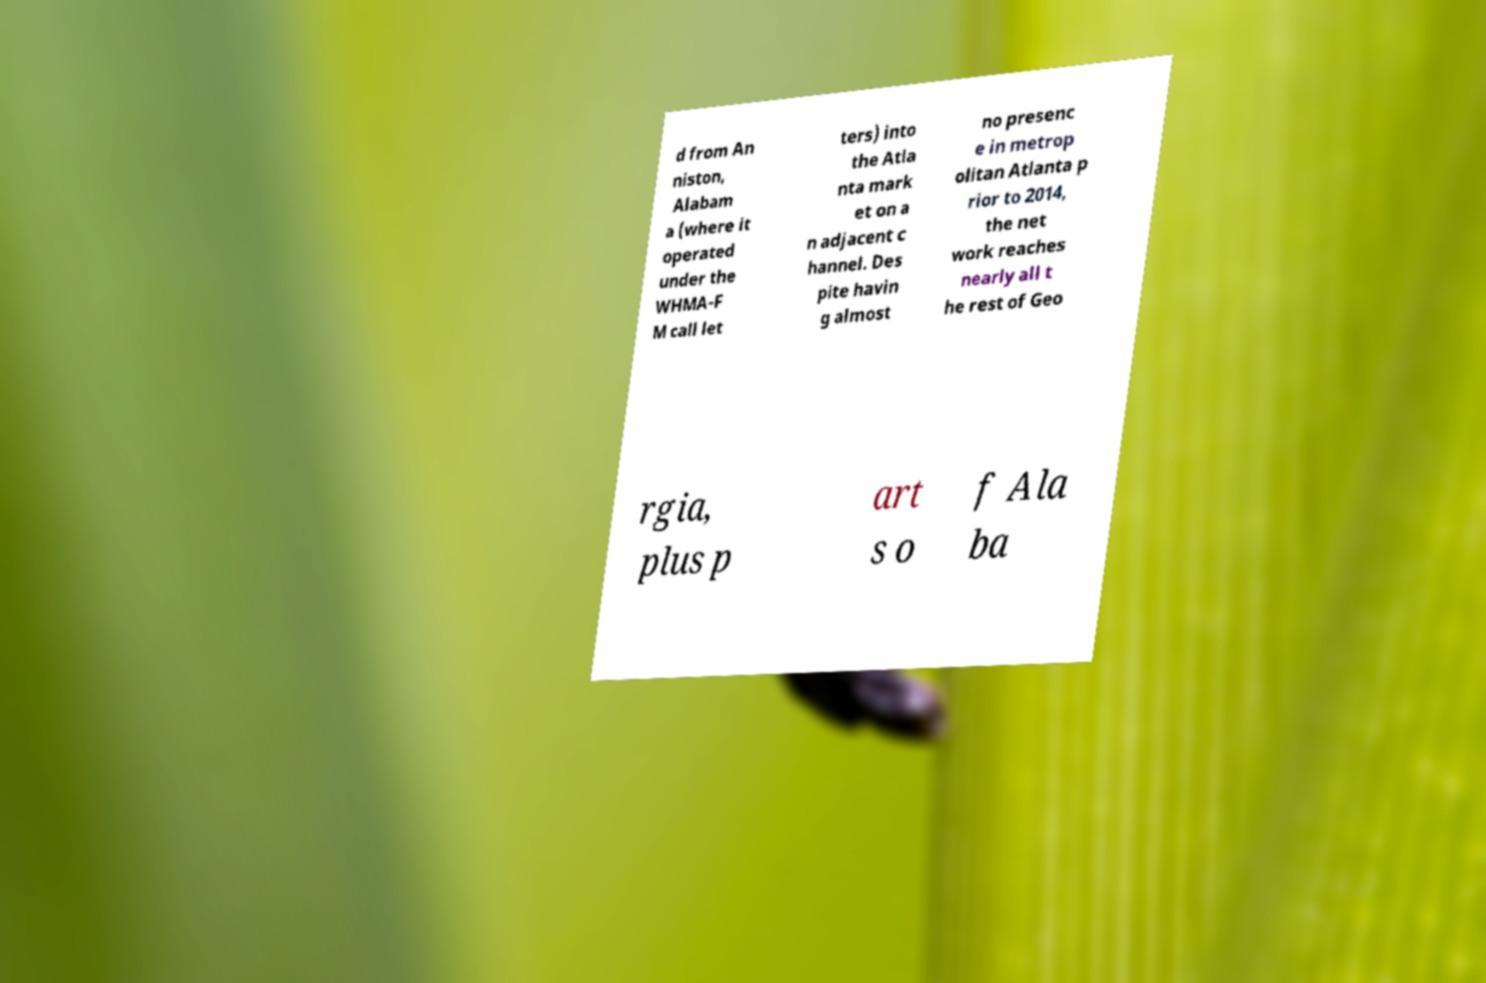Could you extract and type out the text from this image? d from An niston, Alabam a (where it operated under the WHMA-F M call let ters) into the Atla nta mark et on a n adjacent c hannel. Des pite havin g almost no presenc e in metrop olitan Atlanta p rior to 2014, the net work reaches nearly all t he rest of Geo rgia, plus p art s o f Ala ba 